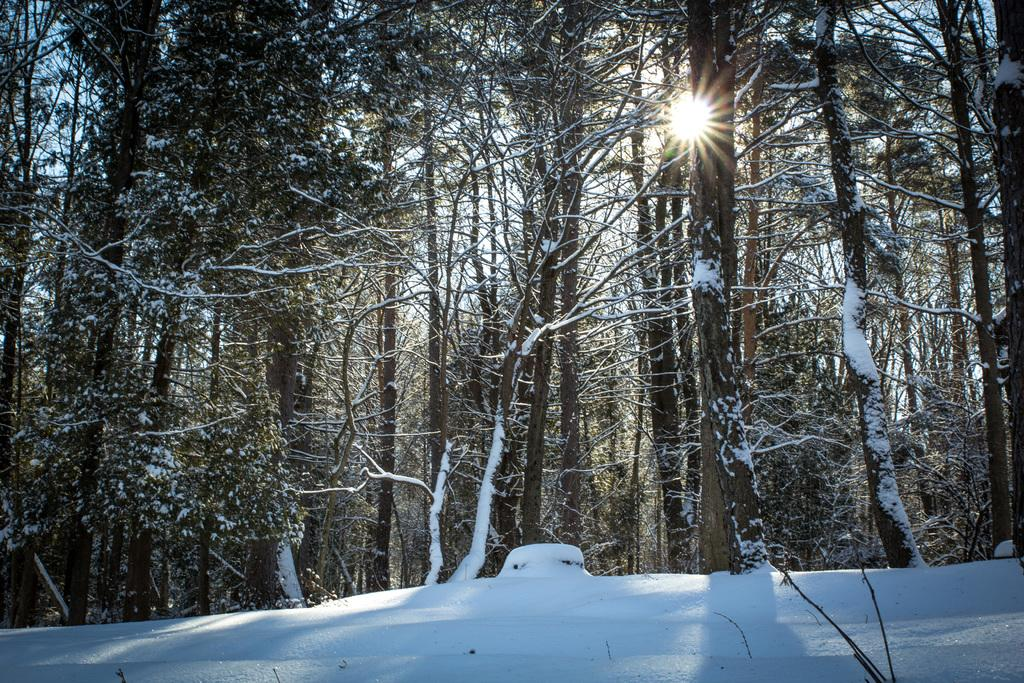What type of vegetation can be seen in the image? There are trees in the image. What is the weather like in the image? There is snow visible in the image, suggesting a cold or wintery environment. Can the sun be seen in the image? Yes, the sun is observable in the image. What type of station is the fireman working at in the image? There is no fireman or station present in the image. How many tickets can be seen in the image? There are no tickets visible in the image. 